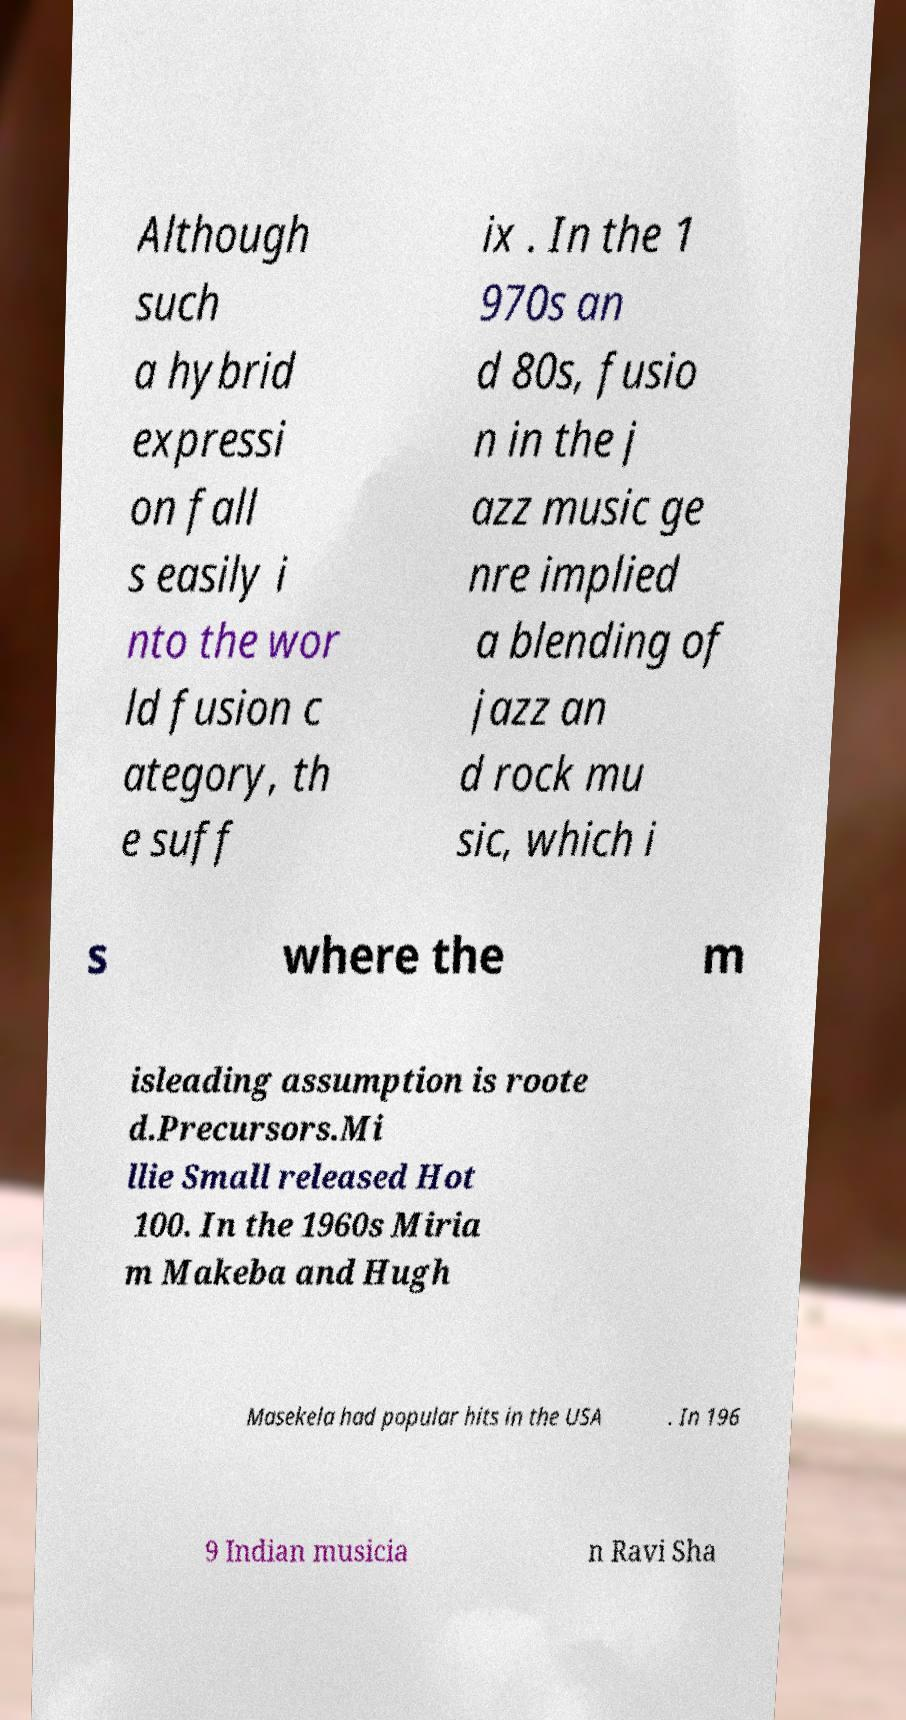Can you read and provide the text displayed in the image?This photo seems to have some interesting text. Can you extract and type it out for me? Although such a hybrid expressi on fall s easily i nto the wor ld fusion c ategory, th e suff ix . In the 1 970s an d 80s, fusio n in the j azz music ge nre implied a blending of jazz an d rock mu sic, which i s where the m isleading assumption is roote d.Precursors.Mi llie Small released Hot 100. In the 1960s Miria m Makeba and Hugh Masekela had popular hits in the USA . In 196 9 Indian musicia n Ravi Sha 